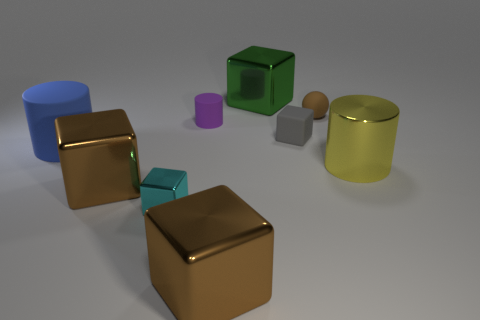What is the color of the tiny block that is behind the small object that is in front of the small cube behind the large blue rubber object?
Keep it short and to the point. Gray. How many cubes have the same color as the sphere?
Give a very brief answer. 2. How many big things are either brown balls or purple rubber spheres?
Offer a very short reply. 0. Is there a large metallic object of the same shape as the blue rubber object?
Keep it short and to the point. Yes. Does the blue matte object have the same shape as the yellow metallic thing?
Your answer should be very brief. Yes. There is a tiny thing in front of the big cylinder on the right side of the tiny gray rubber cube; what color is it?
Keep it short and to the point. Cyan. The rubber block that is the same size as the cyan shiny thing is what color?
Give a very brief answer. Gray. What number of rubber things are purple spheres or large cubes?
Ensure brevity in your answer.  0. What number of brown balls are in front of the big shiny block that is in front of the tiny metallic object?
Keep it short and to the point. 0. How many things are large brown blocks or tiny rubber objects that are on the left side of the green metallic thing?
Give a very brief answer. 3. 